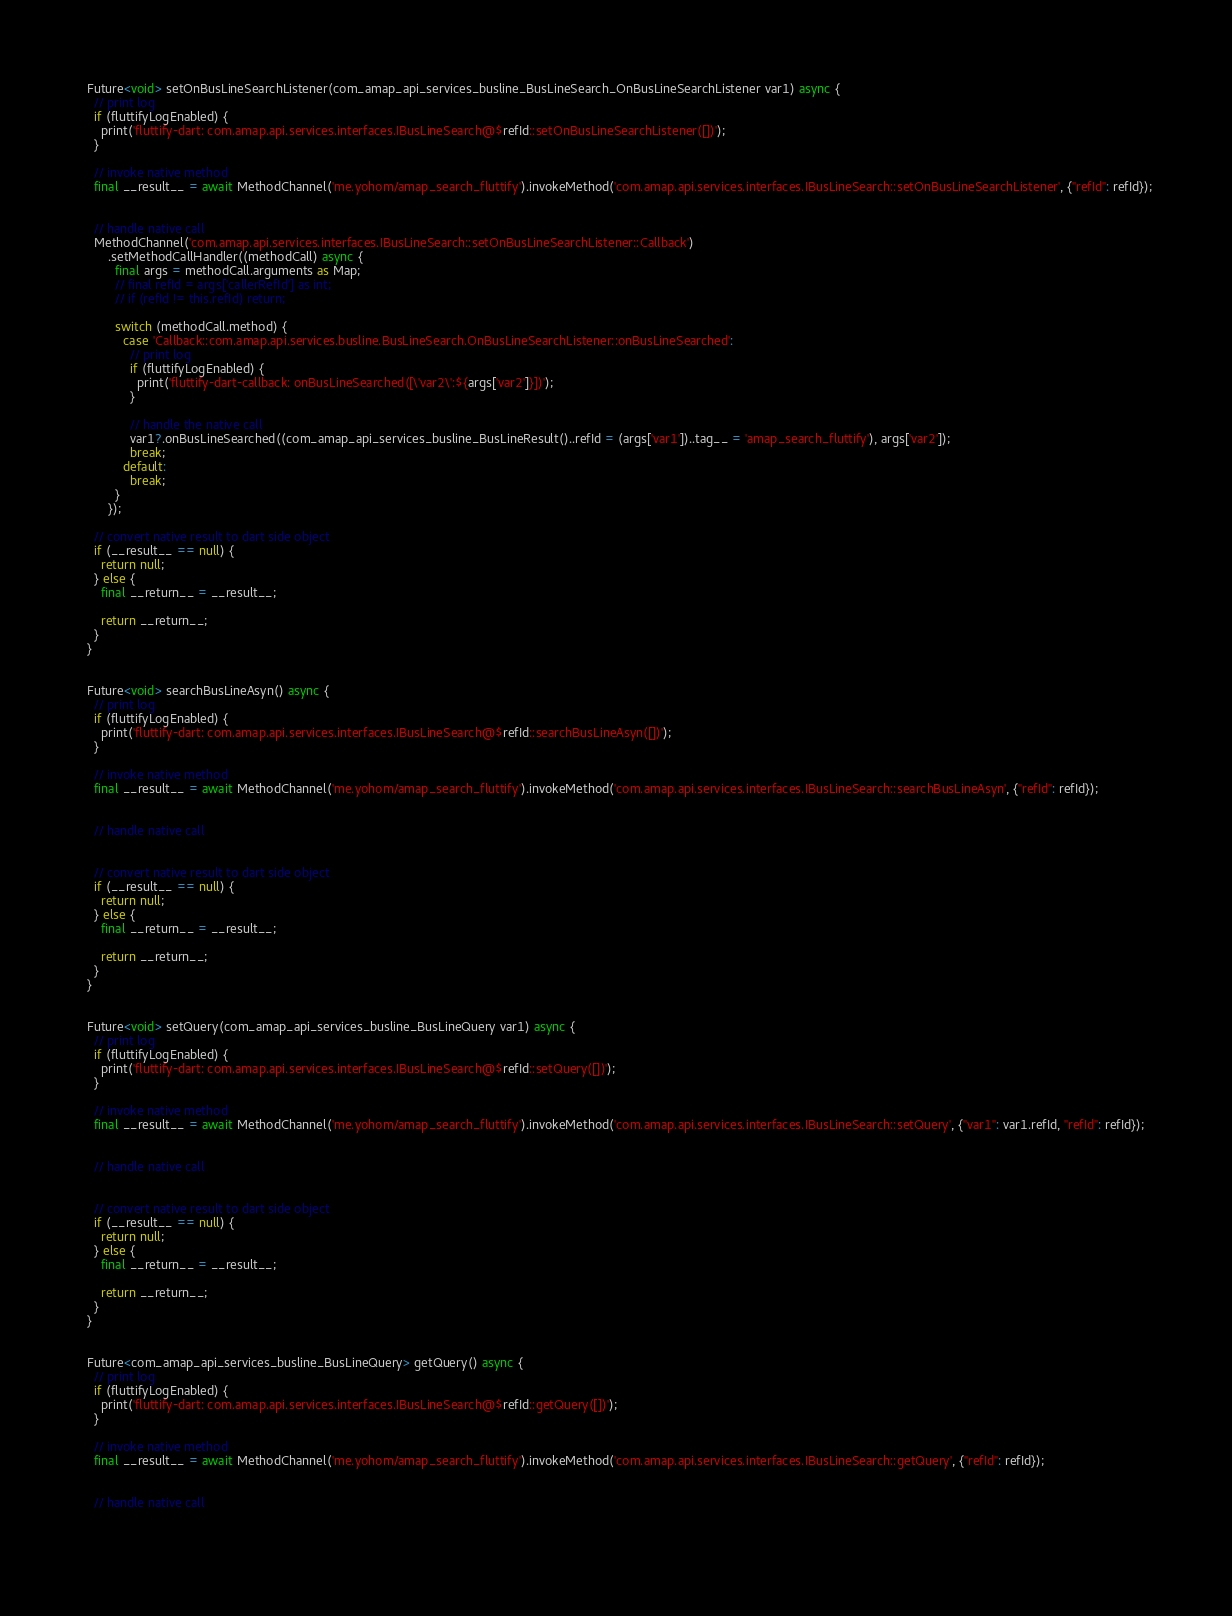Convert code to text. <code><loc_0><loc_0><loc_500><loc_500><_Dart_>  Future<void> setOnBusLineSearchListener(com_amap_api_services_busline_BusLineSearch_OnBusLineSearchListener var1) async {
    // print log
    if (fluttifyLogEnabled) {
      print('fluttify-dart: com.amap.api.services.interfaces.IBusLineSearch@$refId::setOnBusLineSearchListener([])');
    }
  
    // invoke native method
    final __result__ = await MethodChannel('me.yohom/amap_search_fluttify').invokeMethod('com.amap.api.services.interfaces.IBusLineSearch::setOnBusLineSearchListener', {"refId": refId});
  
  
    // handle native call
    MethodChannel('com.amap.api.services.interfaces.IBusLineSearch::setOnBusLineSearchListener::Callback')
        .setMethodCallHandler((methodCall) async {
          final args = methodCall.arguments as Map;
          // final refId = args['callerRefId'] as int;
          // if (refId != this.refId) return;
  
          switch (methodCall.method) {
            case 'Callback::com.amap.api.services.busline.BusLineSearch.OnBusLineSearchListener::onBusLineSearched':
              // print log
              if (fluttifyLogEnabled) {
                print('fluttify-dart-callback: onBusLineSearched([\'var2\':${args['var2']}])');
              }
        
              // handle the native call
              var1?.onBusLineSearched((com_amap_api_services_busline_BusLineResult()..refId = (args['var1'])..tag__ = 'amap_search_fluttify'), args['var2']);
              break;
            default:
              break;
          }
        });
  
    // convert native result to dart side object
    if (__result__ == null) {
      return null;
    } else {
      final __return__ = __result__;
    
      return __return__;
    }
  }
  
  
  Future<void> searchBusLineAsyn() async {
    // print log
    if (fluttifyLogEnabled) {
      print('fluttify-dart: com.amap.api.services.interfaces.IBusLineSearch@$refId::searchBusLineAsyn([])');
    }
  
    // invoke native method
    final __result__ = await MethodChannel('me.yohom/amap_search_fluttify').invokeMethod('com.amap.api.services.interfaces.IBusLineSearch::searchBusLineAsyn', {"refId": refId});
  
  
    // handle native call
  
  
    // convert native result to dart side object
    if (__result__ == null) {
      return null;
    } else {
      final __return__ = __result__;
    
      return __return__;
    }
  }
  
  
  Future<void> setQuery(com_amap_api_services_busline_BusLineQuery var1) async {
    // print log
    if (fluttifyLogEnabled) {
      print('fluttify-dart: com.amap.api.services.interfaces.IBusLineSearch@$refId::setQuery([])');
    }
  
    // invoke native method
    final __result__ = await MethodChannel('me.yohom/amap_search_fluttify').invokeMethod('com.amap.api.services.interfaces.IBusLineSearch::setQuery', {"var1": var1.refId, "refId": refId});
  
  
    // handle native call
  
  
    // convert native result to dart side object
    if (__result__ == null) {
      return null;
    } else {
      final __return__ = __result__;
    
      return __return__;
    }
  }
  
  
  Future<com_amap_api_services_busline_BusLineQuery> getQuery() async {
    // print log
    if (fluttifyLogEnabled) {
      print('fluttify-dart: com.amap.api.services.interfaces.IBusLineSearch@$refId::getQuery([])');
    }
  
    // invoke native method
    final __result__ = await MethodChannel('me.yohom/amap_search_fluttify').invokeMethod('com.amap.api.services.interfaces.IBusLineSearch::getQuery', {"refId": refId});
  
  
    // handle native call
  
  </code> 